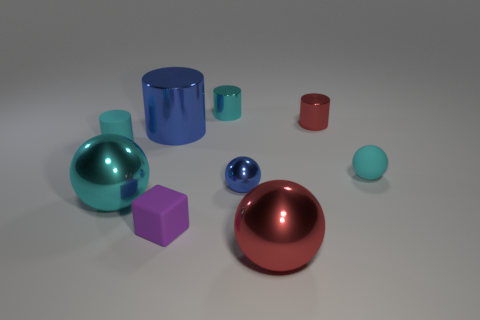Subtract all tiny rubber cylinders. How many cylinders are left? 3 Subtract all blue cylinders. How many cylinders are left? 3 Subtract all blocks. How many objects are left? 8 Subtract all red cylinders. Subtract all green cubes. How many cylinders are left? 3 Subtract all gray cubes. How many purple balls are left? 0 Subtract all blue shiny balls. Subtract all small matte cylinders. How many objects are left? 7 Add 4 cyan metallic balls. How many cyan metallic balls are left? 5 Add 9 purple matte objects. How many purple matte objects exist? 10 Add 1 brown matte objects. How many objects exist? 10 Subtract 0 brown cylinders. How many objects are left? 9 